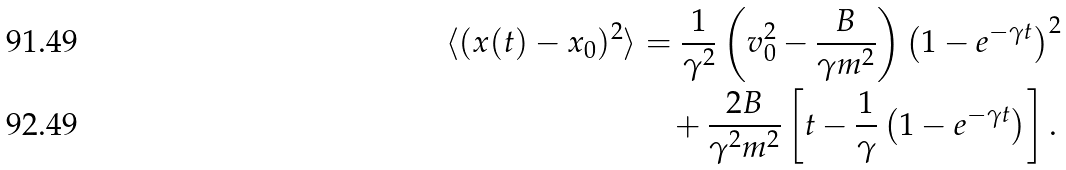Convert formula to latex. <formula><loc_0><loc_0><loc_500><loc_500>\langle ( x ( t ) - x _ { 0 } ) ^ { 2 } \rangle & = \frac { 1 } { \gamma ^ { 2 } } \left ( v _ { 0 } ^ { 2 } - \frac { B } { \gamma m ^ { 2 } } \right ) \left ( 1 - e ^ { - \gamma t } \right ) ^ { 2 } \\ & \quad + \frac { 2 B } { \gamma ^ { 2 } m ^ { 2 } } \left [ t - \frac { 1 } { \gamma } \left ( 1 - e ^ { - \gamma t } \right ) \right ] .</formula> 